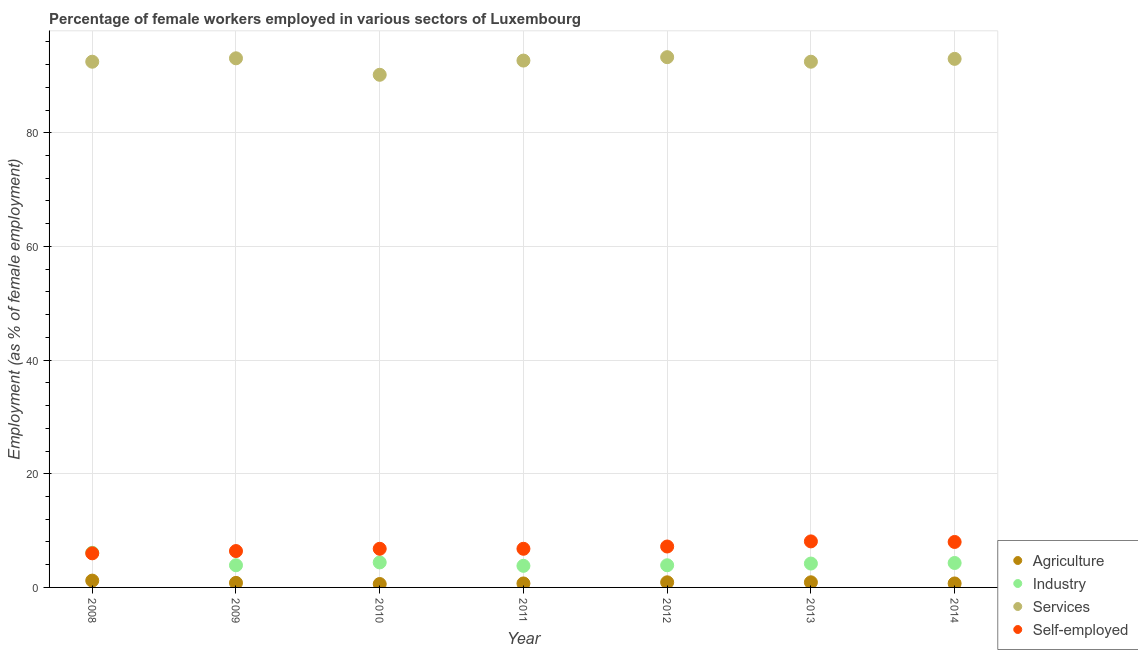Is the number of dotlines equal to the number of legend labels?
Offer a terse response. Yes. What is the percentage of female workers in agriculture in 2010?
Provide a short and direct response. 0.6. Across all years, what is the maximum percentage of female workers in industry?
Your answer should be very brief. 6.1. Across all years, what is the minimum percentage of self employed female workers?
Your response must be concise. 6. In which year was the percentage of self employed female workers maximum?
Your answer should be very brief. 2013. In which year was the percentage of female workers in agriculture minimum?
Ensure brevity in your answer.  2010. What is the total percentage of female workers in industry in the graph?
Offer a very short reply. 30.6. What is the difference between the percentage of female workers in industry in 2012 and that in 2013?
Offer a terse response. -0.3. What is the difference between the percentage of female workers in services in 2013 and the percentage of self employed female workers in 2009?
Keep it short and to the point. 86.1. What is the average percentage of female workers in agriculture per year?
Your answer should be compact. 0.83. In the year 2014, what is the difference between the percentage of female workers in services and percentage of female workers in industry?
Offer a very short reply. 88.7. What is the ratio of the percentage of self employed female workers in 2008 to that in 2014?
Provide a succinct answer. 0.75. Is the difference between the percentage of female workers in agriculture in 2013 and 2014 greater than the difference between the percentage of self employed female workers in 2013 and 2014?
Your answer should be very brief. Yes. What is the difference between the highest and the second highest percentage of female workers in services?
Provide a succinct answer. 0.2. What is the difference between the highest and the lowest percentage of female workers in agriculture?
Your response must be concise. 0.6. Is the percentage of female workers in industry strictly less than the percentage of female workers in agriculture over the years?
Keep it short and to the point. No. How many dotlines are there?
Offer a very short reply. 4. How many years are there in the graph?
Provide a short and direct response. 7. Are the values on the major ticks of Y-axis written in scientific E-notation?
Your response must be concise. No. Does the graph contain any zero values?
Give a very brief answer. No. Does the graph contain grids?
Offer a terse response. Yes. How many legend labels are there?
Provide a succinct answer. 4. How are the legend labels stacked?
Your answer should be compact. Vertical. What is the title of the graph?
Your answer should be compact. Percentage of female workers employed in various sectors of Luxembourg. What is the label or title of the X-axis?
Your answer should be very brief. Year. What is the label or title of the Y-axis?
Keep it short and to the point. Employment (as % of female employment). What is the Employment (as % of female employment) in Agriculture in 2008?
Your response must be concise. 1.2. What is the Employment (as % of female employment) of Industry in 2008?
Provide a short and direct response. 6.1. What is the Employment (as % of female employment) in Services in 2008?
Provide a short and direct response. 92.5. What is the Employment (as % of female employment) of Self-employed in 2008?
Offer a terse response. 6. What is the Employment (as % of female employment) of Agriculture in 2009?
Provide a short and direct response. 0.8. What is the Employment (as % of female employment) of Industry in 2009?
Provide a short and direct response. 3.9. What is the Employment (as % of female employment) of Services in 2009?
Your answer should be compact. 93.1. What is the Employment (as % of female employment) in Self-employed in 2009?
Make the answer very short. 6.4. What is the Employment (as % of female employment) of Agriculture in 2010?
Your answer should be very brief. 0.6. What is the Employment (as % of female employment) in Industry in 2010?
Offer a very short reply. 4.4. What is the Employment (as % of female employment) of Services in 2010?
Provide a succinct answer. 90.2. What is the Employment (as % of female employment) in Self-employed in 2010?
Your answer should be very brief. 6.8. What is the Employment (as % of female employment) in Agriculture in 2011?
Keep it short and to the point. 0.7. What is the Employment (as % of female employment) of Industry in 2011?
Your answer should be compact. 3.8. What is the Employment (as % of female employment) of Services in 2011?
Keep it short and to the point. 92.7. What is the Employment (as % of female employment) of Self-employed in 2011?
Your response must be concise. 6.8. What is the Employment (as % of female employment) of Agriculture in 2012?
Offer a very short reply. 0.9. What is the Employment (as % of female employment) in Industry in 2012?
Offer a very short reply. 3.9. What is the Employment (as % of female employment) of Services in 2012?
Ensure brevity in your answer.  93.3. What is the Employment (as % of female employment) in Self-employed in 2012?
Keep it short and to the point. 7.2. What is the Employment (as % of female employment) in Agriculture in 2013?
Give a very brief answer. 0.9. What is the Employment (as % of female employment) in Industry in 2013?
Make the answer very short. 4.2. What is the Employment (as % of female employment) in Services in 2013?
Offer a very short reply. 92.5. What is the Employment (as % of female employment) in Self-employed in 2013?
Offer a very short reply. 8.1. What is the Employment (as % of female employment) of Agriculture in 2014?
Provide a short and direct response. 0.7. What is the Employment (as % of female employment) in Industry in 2014?
Make the answer very short. 4.3. What is the Employment (as % of female employment) in Services in 2014?
Your answer should be very brief. 93. What is the Employment (as % of female employment) in Self-employed in 2014?
Keep it short and to the point. 8. Across all years, what is the maximum Employment (as % of female employment) in Agriculture?
Your answer should be very brief. 1.2. Across all years, what is the maximum Employment (as % of female employment) in Industry?
Provide a short and direct response. 6.1. Across all years, what is the maximum Employment (as % of female employment) of Services?
Your response must be concise. 93.3. Across all years, what is the maximum Employment (as % of female employment) of Self-employed?
Your response must be concise. 8.1. Across all years, what is the minimum Employment (as % of female employment) of Agriculture?
Your answer should be very brief. 0.6. Across all years, what is the minimum Employment (as % of female employment) of Industry?
Your answer should be very brief. 3.8. Across all years, what is the minimum Employment (as % of female employment) of Services?
Your answer should be compact. 90.2. Across all years, what is the minimum Employment (as % of female employment) in Self-employed?
Keep it short and to the point. 6. What is the total Employment (as % of female employment) in Agriculture in the graph?
Provide a short and direct response. 5.8. What is the total Employment (as % of female employment) in Industry in the graph?
Offer a very short reply. 30.6. What is the total Employment (as % of female employment) of Services in the graph?
Offer a terse response. 647.3. What is the total Employment (as % of female employment) of Self-employed in the graph?
Provide a short and direct response. 49.3. What is the difference between the Employment (as % of female employment) in Self-employed in 2008 and that in 2009?
Ensure brevity in your answer.  -0.4. What is the difference between the Employment (as % of female employment) of Agriculture in 2008 and that in 2010?
Make the answer very short. 0.6. What is the difference between the Employment (as % of female employment) of Self-employed in 2008 and that in 2010?
Provide a short and direct response. -0.8. What is the difference between the Employment (as % of female employment) in Agriculture in 2008 and that in 2011?
Your answer should be very brief. 0.5. What is the difference between the Employment (as % of female employment) of Industry in 2008 and that in 2012?
Ensure brevity in your answer.  2.2. What is the difference between the Employment (as % of female employment) of Self-employed in 2008 and that in 2013?
Ensure brevity in your answer.  -2.1. What is the difference between the Employment (as % of female employment) of Self-employed in 2008 and that in 2014?
Your response must be concise. -2. What is the difference between the Employment (as % of female employment) in Self-employed in 2009 and that in 2010?
Keep it short and to the point. -0.4. What is the difference between the Employment (as % of female employment) of Agriculture in 2009 and that in 2011?
Offer a terse response. 0.1. What is the difference between the Employment (as % of female employment) of Industry in 2009 and that in 2011?
Provide a succinct answer. 0.1. What is the difference between the Employment (as % of female employment) in Services in 2009 and that in 2011?
Offer a very short reply. 0.4. What is the difference between the Employment (as % of female employment) in Self-employed in 2009 and that in 2011?
Your answer should be very brief. -0.4. What is the difference between the Employment (as % of female employment) in Agriculture in 2009 and that in 2012?
Provide a short and direct response. -0.1. What is the difference between the Employment (as % of female employment) of Industry in 2009 and that in 2012?
Your response must be concise. 0. What is the difference between the Employment (as % of female employment) of Self-employed in 2009 and that in 2012?
Offer a terse response. -0.8. What is the difference between the Employment (as % of female employment) of Agriculture in 2009 and that in 2013?
Ensure brevity in your answer.  -0.1. What is the difference between the Employment (as % of female employment) in Services in 2009 and that in 2013?
Offer a very short reply. 0.6. What is the difference between the Employment (as % of female employment) in Agriculture in 2009 and that in 2014?
Your response must be concise. 0.1. What is the difference between the Employment (as % of female employment) of Industry in 2009 and that in 2014?
Make the answer very short. -0.4. What is the difference between the Employment (as % of female employment) of Services in 2009 and that in 2014?
Provide a succinct answer. 0.1. What is the difference between the Employment (as % of female employment) of Services in 2010 and that in 2012?
Keep it short and to the point. -3.1. What is the difference between the Employment (as % of female employment) of Agriculture in 2010 and that in 2013?
Keep it short and to the point. -0.3. What is the difference between the Employment (as % of female employment) in Industry in 2010 and that in 2013?
Your answer should be compact. 0.2. What is the difference between the Employment (as % of female employment) of Self-employed in 2010 and that in 2014?
Your answer should be compact. -1.2. What is the difference between the Employment (as % of female employment) in Agriculture in 2011 and that in 2013?
Offer a terse response. -0.2. What is the difference between the Employment (as % of female employment) of Agriculture in 2011 and that in 2014?
Provide a short and direct response. 0. What is the difference between the Employment (as % of female employment) of Industry in 2011 and that in 2014?
Make the answer very short. -0.5. What is the difference between the Employment (as % of female employment) in Services in 2011 and that in 2014?
Your answer should be very brief. -0.3. What is the difference between the Employment (as % of female employment) in Self-employed in 2011 and that in 2014?
Your answer should be compact. -1.2. What is the difference between the Employment (as % of female employment) in Agriculture in 2012 and that in 2013?
Your answer should be very brief. 0. What is the difference between the Employment (as % of female employment) in Industry in 2012 and that in 2013?
Give a very brief answer. -0.3. What is the difference between the Employment (as % of female employment) of Self-employed in 2012 and that in 2013?
Keep it short and to the point. -0.9. What is the difference between the Employment (as % of female employment) in Industry in 2012 and that in 2014?
Provide a succinct answer. -0.4. What is the difference between the Employment (as % of female employment) in Services in 2012 and that in 2014?
Your answer should be very brief. 0.3. What is the difference between the Employment (as % of female employment) of Self-employed in 2012 and that in 2014?
Provide a short and direct response. -0.8. What is the difference between the Employment (as % of female employment) of Agriculture in 2013 and that in 2014?
Keep it short and to the point. 0.2. What is the difference between the Employment (as % of female employment) of Industry in 2013 and that in 2014?
Give a very brief answer. -0.1. What is the difference between the Employment (as % of female employment) of Self-employed in 2013 and that in 2014?
Give a very brief answer. 0.1. What is the difference between the Employment (as % of female employment) in Agriculture in 2008 and the Employment (as % of female employment) in Industry in 2009?
Your answer should be compact. -2.7. What is the difference between the Employment (as % of female employment) in Agriculture in 2008 and the Employment (as % of female employment) in Services in 2009?
Make the answer very short. -91.9. What is the difference between the Employment (as % of female employment) in Industry in 2008 and the Employment (as % of female employment) in Services in 2009?
Your answer should be compact. -87. What is the difference between the Employment (as % of female employment) in Services in 2008 and the Employment (as % of female employment) in Self-employed in 2009?
Provide a short and direct response. 86.1. What is the difference between the Employment (as % of female employment) in Agriculture in 2008 and the Employment (as % of female employment) in Industry in 2010?
Offer a terse response. -3.2. What is the difference between the Employment (as % of female employment) in Agriculture in 2008 and the Employment (as % of female employment) in Services in 2010?
Give a very brief answer. -89. What is the difference between the Employment (as % of female employment) of Agriculture in 2008 and the Employment (as % of female employment) of Self-employed in 2010?
Offer a very short reply. -5.6. What is the difference between the Employment (as % of female employment) of Industry in 2008 and the Employment (as % of female employment) of Services in 2010?
Offer a very short reply. -84.1. What is the difference between the Employment (as % of female employment) in Industry in 2008 and the Employment (as % of female employment) in Self-employed in 2010?
Your answer should be compact. -0.7. What is the difference between the Employment (as % of female employment) of Services in 2008 and the Employment (as % of female employment) of Self-employed in 2010?
Offer a terse response. 85.7. What is the difference between the Employment (as % of female employment) in Agriculture in 2008 and the Employment (as % of female employment) in Industry in 2011?
Provide a short and direct response. -2.6. What is the difference between the Employment (as % of female employment) of Agriculture in 2008 and the Employment (as % of female employment) of Services in 2011?
Your response must be concise. -91.5. What is the difference between the Employment (as % of female employment) in Agriculture in 2008 and the Employment (as % of female employment) in Self-employed in 2011?
Provide a succinct answer. -5.6. What is the difference between the Employment (as % of female employment) in Industry in 2008 and the Employment (as % of female employment) in Services in 2011?
Keep it short and to the point. -86.6. What is the difference between the Employment (as % of female employment) of Industry in 2008 and the Employment (as % of female employment) of Self-employed in 2011?
Provide a succinct answer. -0.7. What is the difference between the Employment (as % of female employment) of Services in 2008 and the Employment (as % of female employment) of Self-employed in 2011?
Ensure brevity in your answer.  85.7. What is the difference between the Employment (as % of female employment) in Agriculture in 2008 and the Employment (as % of female employment) in Services in 2012?
Make the answer very short. -92.1. What is the difference between the Employment (as % of female employment) in Industry in 2008 and the Employment (as % of female employment) in Services in 2012?
Your response must be concise. -87.2. What is the difference between the Employment (as % of female employment) in Services in 2008 and the Employment (as % of female employment) in Self-employed in 2012?
Your answer should be very brief. 85.3. What is the difference between the Employment (as % of female employment) in Agriculture in 2008 and the Employment (as % of female employment) in Industry in 2013?
Give a very brief answer. -3. What is the difference between the Employment (as % of female employment) in Agriculture in 2008 and the Employment (as % of female employment) in Services in 2013?
Provide a short and direct response. -91.3. What is the difference between the Employment (as % of female employment) in Agriculture in 2008 and the Employment (as % of female employment) in Self-employed in 2013?
Offer a terse response. -6.9. What is the difference between the Employment (as % of female employment) of Industry in 2008 and the Employment (as % of female employment) of Services in 2013?
Offer a very short reply. -86.4. What is the difference between the Employment (as % of female employment) in Industry in 2008 and the Employment (as % of female employment) in Self-employed in 2013?
Provide a succinct answer. -2. What is the difference between the Employment (as % of female employment) in Services in 2008 and the Employment (as % of female employment) in Self-employed in 2013?
Offer a very short reply. 84.4. What is the difference between the Employment (as % of female employment) in Agriculture in 2008 and the Employment (as % of female employment) in Services in 2014?
Your answer should be compact. -91.8. What is the difference between the Employment (as % of female employment) of Industry in 2008 and the Employment (as % of female employment) of Services in 2014?
Provide a short and direct response. -86.9. What is the difference between the Employment (as % of female employment) in Industry in 2008 and the Employment (as % of female employment) in Self-employed in 2014?
Make the answer very short. -1.9. What is the difference between the Employment (as % of female employment) in Services in 2008 and the Employment (as % of female employment) in Self-employed in 2014?
Offer a very short reply. 84.5. What is the difference between the Employment (as % of female employment) in Agriculture in 2009 and the Employment (as % of female employment) in Services in 2010?
Keep it short and to the point. -89.4. What is the difference between the Employment (as % of female employment) of Agriculture in 2009 and the Employment (as % of female employment) of Self-employed in 2010?
Offer a very short reply. -6. What is the difference between the Employment (as % of female employment) in Industry in 2009 and the Employment (as % of female employment) in Services in 2010?
Make the answer very short. -86.3. What is the difference between the Employment (as % of female employment) of Services in 2009 and the Employment (as % of female employment) of Self-employed in 2010?
Keep it short and to the point. 86.3. What is the difference between the Employment (as % of female employment) of Agriculture in 2009 and the Employment (as % of female employment) of Services in 2011?
Give a very brief answer. -91.9. What is the difference between the Employment (as % of female employment) in Agriculture in 2009 and the Employment (as % of female employment) in Self-employed in 2011?
Ensure brevity in your answer.  -6. What is the difference between the Employment (as % of female employment) of Industry in 2009 and the Employment (as % of female employment) of Services in 2011?
Ensure brevity in your answer.  -88.8. What is the difference between the Employment (as % of female employment) of Industry in 2009 and the Employment (as % of female employment) of Self-employed in 2011?
Your answer should be compact. -2.9. What is the difference between the Employment (as % of female employment) in Services in 2009 and the Employment (as % of female employment) in Self-employed in 2011?
Your response must be concise. 86.3. What is the difference between the Employment (as % of female employment) of Agriculture in 2009 and the Employment (as % of female employment) of Industry in 2012?
Your answer should be very brief. -3.1. What is the difference between the Employment (as % of female employment) of Agriculture in 2009 and the Employment (as % of female employment) of Services in 2012?
Your answer should be very brief. -92.5. What is the difference between the Employment (as % of female employment) in Agriculture in 2009 and the Employment (as % of female employment) in Self-employed in 2012?
Ensure brevity in your answer.  -6.4. What is the difference between the Employment (as % of female employment) of Industry in 2009 and the Employment (as % of female employment) of Services in 2012?
Offer a very short reply. -89.4. What is the difference between the Employment (as % of female employment) of Industry in 2009 and the Employment (as % of female employment) of Self-employed in 2012?
Ensure brevity in your answer.  -3.3. What is the difference between the Employment (as % of female employment) in Services in 2009 and the Employment (as % of female employment) in Self-employed in 2012?
Keep it short and to the point. 85.9. What is the difference between the Employment (as % of female employment) of Agriculture in 2009 and the Employment (as % of female employment) of Industry in 2013?
Give a very brief answer. -3.4. What is the difference between the Employment (as % of female employment) in Agriculture in 2009 and the Employment (as % of female employment) in Services in 2013?
Ensure brevity in your answer.  -91.7. What is the difference between the Employment (as % of female employment) of Industry in 2009 and the Employment (as % of female employment) of Services in 2013?
Ensure brevity in your answer.  -88.6. What is the difference between the Employment (as % of female employment) in Services in 2009 and the Employment (as % of female employment) in Self-employed in 2013?
Offer a terse response. 85. What is the difference between the Employment (as % of female employment) in Agriculture in 2009 and the Employment (as % of female employment) in Industry in 2014?
Ensure brevity in your answer.  -3.5. What is the difference between the Employment (as % of female employment) of Agriculture in 2009 and the Employment (as % of female employment) of Services in 2014?
Provide a succinct answer. -92.2. What is the difference between the Employment (as % of female employment) in Agriculture in 2009 and the Employment (as % of female employment) in Self-employed in 2014?
Ensure brevity in your answer.  -7.2. What is the difference between the Employment (as % of female employment) in Industry in 2009 and the Employment (as % of female employment) in Services in 2014?
Your answer should be compact. -89.1. What is the difference between the Employment (as % of female employment) in Industry in 2009 and the Employment (as % of female employment) in Self-employed in 2014?
Offer a terse response. -4.1. What is the difference between the Employment (as % of female employment) in Services in 2009 and the Employment (as % of female employment) in Self-employed in 2014?
Your answer should be very brief. 85.1. What is the difference between the Employment (as % of female employment) of Agriculture in 2010 and the Employment (as % of female employment) of Industry in 2011?
Your answer should be compact. -3.2. What is the difference between the Employment (as % of female employment) of Agriculture in 2010 and the Employment (as % of female employment) of Services in 2011?
Keep it short and to the point. -92.1. What is the difference between the Employment (as % of female employment) of Agriculture in 2010 and the Employment (as % of female employment) of Self-employed in 2011?
Offer a very short reply. -6.2. What is the difference between the Employment (as % of female employment) of Industry in 2010 and the Employment (as % of female employment) of Services in 2011?
Your answer should be very brief. -88.3. What is the difference between the Employment (as % of female employment) in Services in 2010 and the Employment (as % of female employment) in Self-employed in 2011?
Give a very brief answer. 83.4. What is the difference between the Employment (as % of female employment) of Agriculture in 2010 and the Employment (as % of female employment) of Industry in 2012?
Ensure brevity in your answer.  -3.3. What is the difference between the Employment (as % of female employment) of Agriculture in 2010 and the Employment (as % of female employment) of Services in 2012?
Ensure brevity in your answer.  -92.7. What is the difference between the Employment (as % of female employment) of Agriculture in 2010 and the Employment (as % of female employment) of Self-employed in 2012?
Your response must be concise. -6.6. What is the difference between the Employment (as % of female employment) of Industry in 2010 and the Employment (as % of female employment) of Services in 2012?
Your answer should be very brief. -88.9. What is the difference between the Employment (as % of female employment) of Agriculture in 2010 and the Employment (as % of female employment) of Industry in 2013?
Your answer should be very brief. -3.6. What is the difference between the Employment (as % of female employment) in Agriculture in 2010 and the Employment (as % of female employment) in Services in 2013?
Provide a succinct answer. -91.9. What is the difference between the Employment (as % of female employment) in Industry in 2010 and the Employment (as % of female employment) in Services in 2013?
Make the answer very short. -88.1. What is the difference between the Employment (as % of female employment) of Industry in 2010 and the Employment (as % of female employment) of Self-employed in 2013?
Keep it short and to the point. -3.7. What is the difference between the Employment (as % of female employment) of Services in 2010 and the Employment (as % of female employment) of Self-employed in 2013?
Offer a terse response. 82.1. What is the difference between the Employment (as % of female employment) in Agriculture in 2010 and the Employment (as % of female employment) in Services in 2014?
Make the answer very short. -92.4. What is the difference between the Employment (as % of female employment) in Agriculture in 2010 and the Employment (as % of female employment) in Self-employed in 2014?
Give a very brief answer. -7.4. What is the difference between the Employment (as % of female employment) of Industry in 2010 and the Employment (as % of female employment) of Services in 2014?
Provide a succinct answer. -88.6. What is the difference between the Employment (as % of female employment) of Services in 2010 and the Employment (as % of female employment) of Self-employed in 2014?
Give a very brief answer. 82.2. What is the difference between the Employment (as % of female employment) of Agriculture in 2011 and the Employment (as % of female employment) of Industry in 2012?
Keep it short and to the point. -3.2. What is the difference between the Employment (as % of female employment) of Agriculture in 2011 and the Employment (as % of female employment) of Services in 2012?
Provide a short and direct response. -92.6. What is the difference between the Employment (as % of female employment) in Agriculture in 2011 and the Employment (as % of female employment) in Self-employed in 2012?
Provide a short and direct response. -6.5. What is the difference between the Employment (as % of female employment) in Industry in 2011 and the Employment (as % of female employment) in Services in 2012?
Offer a terse response. -89.5. What is the difference between the Employment (as % of female employment) of Industry in 2011 and the Employment (as % of female employment) of Self-employed in 2012?
Make the answer very short. -3.4. What is the difference between the Employment (as % of female employment) of Services in 2011 and the Employment (as % of female employment) of Self-employed in 2012?
Ensure brevity in your answer.  85.5. What is the difference between the Employment (as % of female employment) in Agriculture in 2011 and the Employment (as % of female employment) in Services in 2013?
Your answer should be very brief. -91.8. What is the difference between the Employment (as % of female employment) of Agriculture in 2011 and the Employment (as % of female employment) of Self-employed in 2013?
Provide a short and direct response. -7.4. What is the difference between the Employment (as % of female employment) in Industry in 2011 and the Employment (as % of female employment) in Services in 2013?
Offer a very short reply. -88.7. What is the difference between the Employment (as % of female employment) of Services in 2011 and the Employment (as % of female employment) of Self-employed in 2013?
Make the answer very short. 84.6. What is the difference between the Employment (as % of female employment) of Agriculture in 2011 and the Employment (as % of female employment) of Services in 2014?
Provide a short and direct response. -92.3. What is the difference between the Employment (as % of female employment) of Agriculture in 2011 and the Employment (as % of female employment) of Self-employed in 2014?
Offer a very short reply. -7.3. What is the difference between the Employment (as % of female employment) of Industry in 2011 and the Employment (as % of female employment) of Services in 2014?
Your response must be concise. -89.2. What is the difference between the Employment (as % of female employment) in Services in 2011 and the Employment (as % of female employment) in Self-employed in 2014?
Offer a terse response. 84.7. What is the difference between the Employment (as % of female employment) in Agriculture in 2012 and the Employment (as % of female employment) in Services in 2013?
Provide a short and direct response. -91.6. What is the difference between the Employment (as % of female employment) of Industry in 2012 and the Employment (as % of female employment) of Services in 2013?
Ensure brevity in your answer.  -88.6. What is the difference between the Employment (as % of female employment) of Services in 2012 and the Employment (as % of female employment) of Self-employed in 2013?
Offer a very short reply. 85.2. What is the difference between the Employment (as % of female employment) in Agriculture in 2012 and the Employment (as % of female employment) in Industry in 2014?
Your answer should be compact. -3.4. What is the difference between the Employment (as % of female employment) in Agriculture in 2012 and the Employment (as % of female employment) in Services in 2014?
Give a very brief answer. -92.1. What is the difference between the Employment (as % of female employment) of Agriculture in 2012 and the Employment (as % of female employment) of Self-employed in 2014?
Offer a terse response. -7.1. What is the difference between the Employment (as % of female employment) of Industry in 2012 and the Employment (as % of female employment) of Services in 2014?
Provide a short and direct response. -89.1. What is the difference between the Employment (as % of female employment) in Services in 2012 and the Employment (as % of female employment) in Self-employed in 2014?
Your response must be concise. 85.3. What is the difference between the Employment (as % of female employment) in Agriculture in 2013 and the Employment (as % of female employment) in Industry in 2014?
Keep it short and to the point. -3.4. What is the difference between the Employment (as % of female employment) of Agriculture in 2013 and the Employment (as % of female employment) of Services in 2014?
Your response must be concise. -92.1. What is the difference between the Employment (as % of female employment) in Industry in 2013 and the Employment (as % of female employment) in Services in 2014?
Your answer should be compact. -88.8. What is the difference between the Employment (as % of female employment) in Services in 2013 and the Employment (as % of female employment) in Self-employed in 2014?
Offer a very short reply. 84.5. What is the average Employment (as % of female employment) of Agriculture per year?
Provide a short and direct response. 0.83. What is the average Employment (as % of female employment) of Industry per year?
Your answer should be very brief. 4.37. What is the average Employment (as % of female employment) in Services per year?
Your answer should be compact. 92.47. What is the average Employment (as % of female employment) in Self-employed per year?
Your response must be concise. 7.04. In the year 2008, what is the difference between the Employment (as % of female employment) of Agriculture and Employment (as % of female employment) of Services?
Keep it short and to the point. -91.3. In the year 2008, what is the difference between the Employment (as % of female employment) in Agriculture and Employment (as % of female employment) in Self-employed?
Ensure brevity in your answer.  -4.8. In the year 2008, what is the difference between the Employment (as % of female employment) in Industry and Employment (as % of female employment) in Services?
Make the answer very short. -86.4. In the year 2008, what is the difference between the Employment (as % of female employment) of Industry and Employment (as % of female employment) of Self-employed?
Provide a succinct answer. 0.1. In the year 2008, what is the difference between the Employment (as % of female employment) in Services and Employment (as % of female employment) in Self-employed?
Keep it short and to the point. 86.5. In the year 2009, what is the difference between the Employment (as % of female employment) in Agriculture and Employment (as % of female employment) in Services?
Offer a terse response. -92.3. In the year 2009, what is the difference between the Employment (as % of female employment) of Agriculture and Employment (as % of female employment) of Self-employed?
Provide a succinct answer. -5.6. In the year 2009, what is the difference between the Employment (as % of female employment) of Industry and Employment (as % of female employment) of Services?
Provide a short and direct response. -89.2. In the year 2009, what is the difference between the Employment (as % of female employment) of Industry and Employment (as % of female employment) of Self-employed?
Offer a terse response. -2.5. In the year 2009, what is the difference between the Employment (as % of female employment) of Services and Employment (as % of female employment) of Self-employed?
Offer a terse response. 86.7. In the year 2010, what is the difference between the Employment (as % of female employment) in Agriculture and Employment (as % of female employment) in Services?
Make the answer very short. -89.6. In the year 2010, what is the difference between the Employment (as % of female employment) of Industry and Employment (as % of female employment) of Services?
Offer a terse response. -85.8. In the year 2010, what is the difference between the Employment (as % of female employment) of Industry and Employment (as % of female employment) of Self-employed?
Keep it short and to the point. -2.4. In the year 2010, what is the difference between the Employment (as % of female employment) of Services and Employment (as % of female employment) of Self-employed?
Provide a short and direct response. 83.4. In the year 2011, what is the difference between the Employment (as % of female employment) in Agriculture and Employment (as % of female employment) in Industry?
Provide a short and direct response. -3.1. In the year 2011, what is the difference between the Employment (as % of female employment) of Agriculture and Employment (as % of female employment) of Services?
Provide a succinct answer. -92. In the year 2011, what is the difference between the Employment (as % of female employment) of Agriculture and Employment (as % of female employment) of Self-employed?
Give a very brief answer. -6.1. In the year 2011, what is the difference between the Employment (as % of female employment) in Industry and Employment (as % of female employment) in Services?
Make the answer very short. -88.9. In the year 2011, what is the difference between the Employment (as % of female employment) in Services and Employment (as % of female employment) in Self-employed?
Your answer should be compact. 85.9. In the year 2012, what is the difference between the Employment (as % of female employment) in Agriculture and Employment (as % of female employment) in Services?
Give a very brief answer. -92.4. In the year 2012, what is the difference between the Employment (as % of female employment) of Agriculture and Employment (as % of female employment) of Self-employed?
Keep it short and to the point. -6.3. In the year 2012, what is the difference between the Employment (as % of female employment) of Industry and Employment (as % of female employment) of Services?
Offer a very short reply. -89.4. In the year 2012, what is the difference between the Employment (as % of female employment) in Industry and Employment (as % of female employment) in Self-employed?
Your response must be concise. -3.3. In the year 2012, what is the difference between the Employment (as % of female employment) of Services and Employment (as % of female employment) of Self-employed?
Keep it short and to the point. 86.1. In the year 2013, what is the difference between the Employment (as % of female employment) in Agriculture and Employment (as % of female employment) in Services?
Your response must be concise. -91.6. In the year 2013, what is the difference between the Employment (as % of female employment) in Industry and Employment (as % of female employment) in Services?
Give a very brief answer. -88.3. In the year 2013, what is the difference between the Employment (as % of female employment) of Industry and Employment (as % of female employment) of Self-employed?
Provide a short and direct response. -3.9. In the year 2013, what is the difference between the Employment (as % of female employment) in Services and Employment (as % of female employment) in Self-employed?
Offer a terse response. 84.4. In the year 2014, what is the difference between the Employment (as % of female employment) of Agriculture and Employment (as % of female employment) of Services?
Give a very brief answer. -92.3. In the year 2014, what is the difference between the Employment (as % of female employment) in Industry and Employment (as % of female employment) in Services?
Provide a short and direct response. -88.7. In the year 2014, what is the difference between the Employment (as % of female employment) of Industry and Employment (as % of female employment) of Self-employed?
Your answer should be very brief. -3.7. In the year 2014, what is the difference between the Employment (as % of female employment) in Services and Employment (as % of female employment) in Self-employed?
Give a very brief answer. 85. What is the ratio of the Employment (as % of female employment) of Agriculture in 2008 to that in 2009?
Offer a terse response. 1.5. What is the ratio of the Employment (as % of female employment) of Industry in 2008 to that in 2009?
Provide a short and direct response. 1.56. What is the ratio of the Employment (as % of female employment) of Services in 2008 to that in 2009?
Give a very brief answer. 0.99. What is the ratio of the Employment (as % of female employment) of Self-employed in 2008 to that in 2009?
Your answer should be compact. 0.94. What is the ratio of the Employment (as % of female employment) of Agriculture in 2008 to that in 2010?
Ensure brevity in your answer.  2. What is the ratio of the Employment (as % of female employment) of Industry in 2008 to that in 2010?
Give a very brief answer. 1.39. What is the ratio of the Employment (as % of female employment) in Services in 2008 to that in 2010?
Provide a short and direct response. 1.03. What is the ratio of the Employment (as % of female employment) of Self-employed in 2008 to that in 2010?
Ensure brevity in your answer.  0.88. What is the ratio of the Employment (as % of female employment) in Agriculture in 2008 to that in 2011?
Your response must be concise. 1.71. What is the ratio of the Employment (as % of female employment) in Industry in 2008 to that in 2011?
Ensure brevity in your answer.  1.61. What is the ratio of the Employment (as % of female employment) of Services in 2008 to that in 2011?
Give a very brief answer. 1. What is the ratio of the Employment (as % of female employment) of Self-employed in 2008 to that in 2011?
Ensure brevity in your answer.  0.88. What is the ratio of the Employment (as % of female employment) in Agriculture in 2008 to that in 2012?
Your answer should be compact. 1.33. What is the ratio of the Employment (as % of female employment) in Industry in 2008 to that in 2012?
Provide a short and direct response. 1.56. What is the ratio of the Employment (as % of female employment) of Industry in 2008 to that in 2013?
Offer a very short reply. 1.45. What is the ratio of the Employment (as % of female employment) in Self-employed in 2008 to that in 2013?
Your answer should be compact. 0.74. What is the ratio of the Employment (as % of female employment) of Agriculture in 2008 to that in 2014?
Your answer should be compact. 1.71. What is the ratio of the Employment (as % of female employment) in Industry in 2008 to that in 2014?
Provide a short and direct response. 1.42. What is the ratio of the Employment (as % of female employment) in Services in 2008 to that in 2014?
Keep it short and to the point. 0.99. What is the ratio of the Employment (as % of female employment) of Industry in 2009 to that in 2010?
Give a very brief answer. 0.89. What is the ratio of the Employment (as % of female employment) in Services in 2009 to that in 2010?
Offer a very short reply. 1.03. What is the ratio of the Employment (as % of female employment) of Agriculture in 2009 to that in 2011?
Your response must be concise. 1.14. What is the ratio of the Employment (as % of female employment) in Industry in 2009 to that in 2011?
Provide a succinct answer. 1.03. What is the ratio of the Employment (as % of female employment) of Services in 2009 to that in 2011?
Provide a short and direct response. 1. What is the ratio of the Employment (as % of female employment) in Self-employed in 2009 to that in 2011?
Your answer should be compact. 0.94. What is the ratio of the Employment (as % of female employment) in Industry in 2009 to that in 2012?
Provide a succinct answer. 1. What is the ratio of the Employment (as % of female employment) in Self-employed in 2009 to that in 2013?
Your answer should be compact. 0.79. What is the ratio of the Employment (as % of female employment) in Industry in 2009 to that in 2014?
Your response must be concise. 0.91. What is the ratio of the Employment (as % of female employment) of Industry in 2010 to that in 2011?
Your answer should be compact. 1.16. What is the ratio of the Employment (as % of female employment) in Self-employed in 2010 to that in 2011?
Keep it short and to the point. 1. What is the ratio of the Employment (as % of female employment) in Agriculture in 2010 to that in 2012?
Ensure brevity in your answer.  0.67. What is the ratio of the Employment (as % of female employment) in Industry in 2010 to that in 2012?
Offer a very short reply. 1.13. What is the ratio of the Employment (as % of female employment) of Services in 2010 to that in 2012?
Make the answer very short. 0.97. What is the ratio of the Employment (as % of female employment) in Industry in 2010 to that in 2013?
Your response must be concise. 1.05. What is the ratio of the Employment (as % of female employment) of Services in 2010 to that in 2013?
Make the answer very short. 0.98. What is the ratio of the Employment (as % of female employment) of Self-employed in 2010 to that in 2013?
Offer a terse response. 0.84. What is the ratio of the Employment (as % of female employment) of Industry in 2010 to that in 2014?
Offer a very short reply. 1.02. What is the ratio of the Employment (as % of female employment) in Services in 2010 to that in 2014?
Give a very brief answer. 0.97. What is the ratio of the Employment (as % of female employment) of Self-employed in 2010 to that in 2014?
Ensure brevity in your answer.  0.85. What is the ratio of the Employment (as % of female employment) in Industry in 2011 to that in 2012?
Provide a succinct answer. 0.97. What is the ratio of the Employment (as % of female employment) in Agriculture in 2011 to that in 2013?
Offer a very short reply. 0.78. What is the ratio of the Employment (as % of female employment) in Industry in 2011 to that in 2013?
Offer a terse response. 0.9. What is the ratio of the Employment (as % of female employment) of Self-employed in 2011 to that in 2013?
Keep it short and to the point. 0.84. What is the ratio of the Employment (as % of female employment) of Industry in 2011 to that in 2014?
Your answer should be very brief. 0.88. What is the ratio of the Employment (as % of female employment) of Self-employed in 2011 to that in 2014?
Give a very brief answer. 0.85. What is the ratio of the Employment (as % of female employment) in Agriculture in 2012 to that in 2013?
Ensure brevity in your answer.  1. What is the ratio of the Employment (as % of female employment) of Industry in 2012 to that in 2013?
Your answer should be very brief. 0.93. What is the ratio of the Employment (as % of female employment) of Services in 2012 to that in 2013?
Your answer should be compact. 1.01. What is the ratio of the Employment (as % of female employment) of Industry in 2012 to that in 2014?
Offer a very short reply. 0.91. What is the ratio of the Employment (as % of female employment) of Services in 2012 to that in 2014?
Your answer should be very brief. 1. What is the ratio of the Employment (as % of female employment) in Agriculture in 2013 to that in 2014?
Your answer should be compact. 1.29. What is the ratio of the Employment (as % of female employment) in Industry in 2013 to that in 2014?
Offer a very short reply. 0.98. What is the ratio of the Employment (as % of female employment) in Services in 2013 to that in 2014?
Offer a very short reply. 0.99. What is the ratio of the Employment (as % of female employment) of Self-employed in 2013 to that in 2014?
Provide a succinct answer. 1.01. What is the difference between the highest and the second highest Employment (as % of female employment) of Industry?
Your response must be concise. 1.7. What is the difference between the highest and the second highest Employment (as % of female employment) in Services?
Your answer should be compact. 0.2. What is the difference between the highest and the lowest Employment (as % of female employment) in Industry?
Keep it short and to the point. 2.3. 